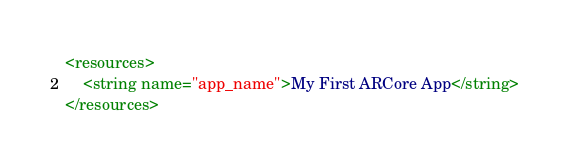Convert code to text. <code><loc_0><loc_0><loc_500><loc_500><_XML_><resources>
    <string name="app_name">My First ARCore App</string>
</resources>
</code> 